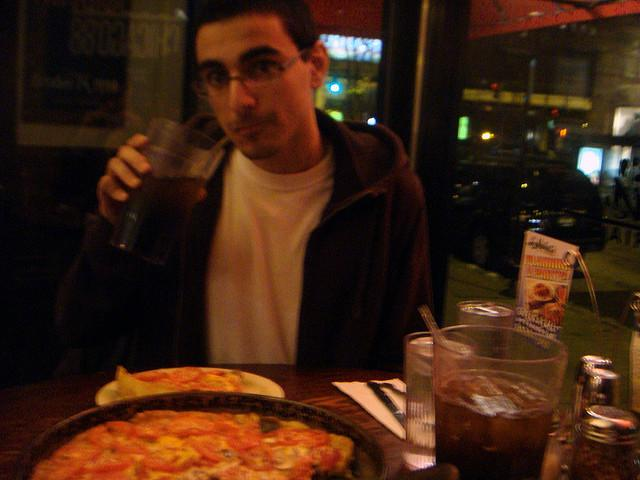What color is the soft drink drank by the man at the pizza store? brown 